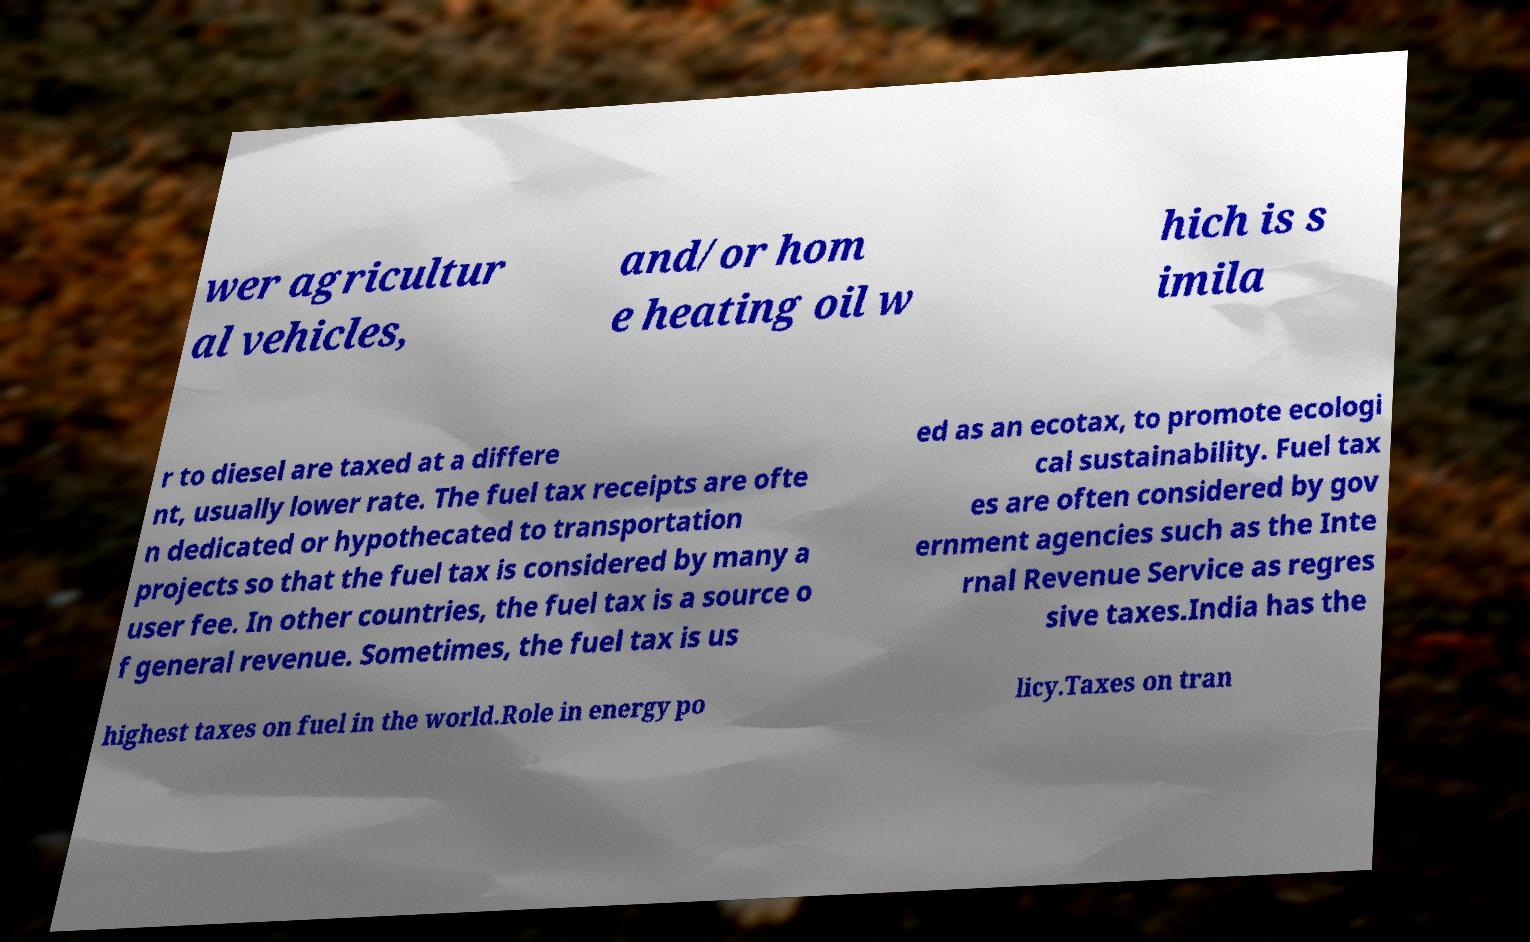Could you extract and type out the text from this image? wer agricultur al vehicles, and/or hom e heating oil w hich is s imila r to diesel are taxed at a differe nt, usually lower rate. The fuel tax receipts are ofte n dedicated or hypothecated to transportation projects so that the fuel tax is considered by many a user fee. In other countries, the fuel tax is a source o f general revenue. Sometimes, the fuel tax is us ed as an ecotax, to promote ecologi cal sustainability. Fuel tax es are often considered by gov ernment agencies such as the Inte rnal Revenue Service as regres sive taxes.India has the highest taxes on fuel in the world.Role in energy po licy.Taxes on tran 